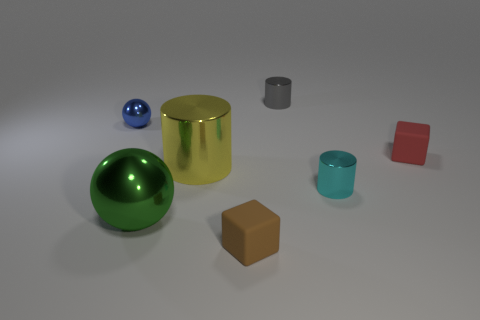How many objects are there and can you describe their shapes? In total, there are six objects in the image, each with a distinct shape: a large gold-colored cylinder, a smaller gray cylinder, a green sphere, a blue sphere, a brown cube, and a red cuboid or brick shape. 